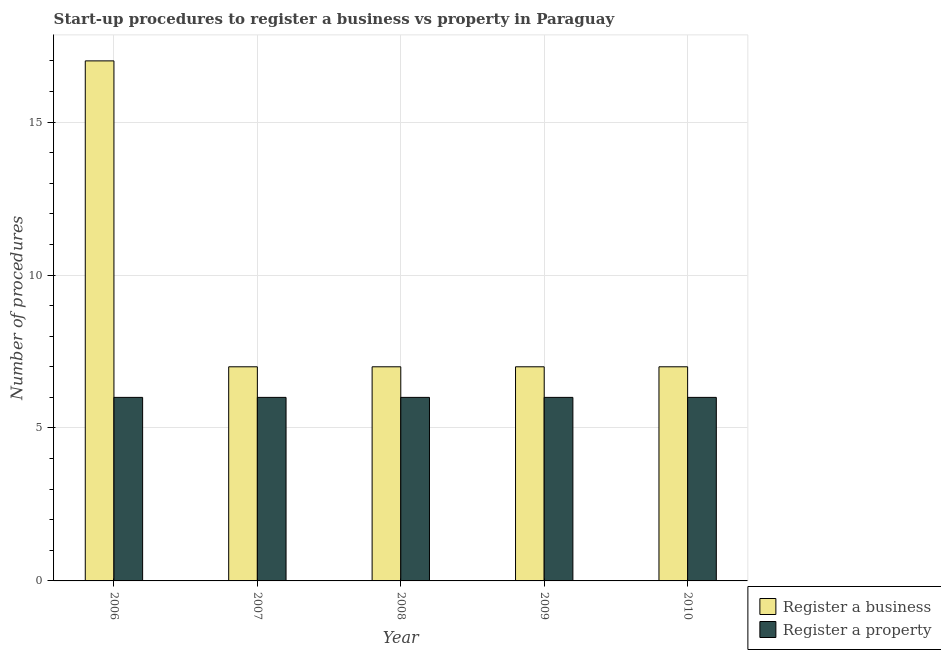How many different coloured bars are there?
Keep it short and to the point. 2. How many groups of bars are there?
Provide a short and direct response. 5. Are the number of bars on each tick of the X-axis equal?
Provide a succinct answer. Yes. How many bars are there on the 4th tick from the left?
Give a very brief answer. 2. How many bars are there on the 1st tick from the right?
Provide a short and direct response. 2. What is the number of procedures to register a business in 2008?
Provide a short and direct response. 7. Across all years, what is the maximum number of procedures to register a business?
Make the answer very short. 17. In which year was the number of procedures to register a property maximum?
Your answer should be compact. 2006. In which year was the number of procedures to register a business minimum?
Give a very brief answer. 2007. What is the total number of procedures to register a business in the graph?
Offer a very short reply. 45. What is the difference between the number of procedures to register a business in 2009 and that in 2010?
Your answer should be very brief. 0. In the year 2008, what is the difference between the number of procedures to register a property and number of procedures to register a business?
Your answer should be very brief. 0. What is the ratio of the number of procedures to register a business in 2006 to that in 2008?
Your answer should be compact. 2.43. Is the number of procedures to register a business in 2006 less than that in 2008?
Provide a short and direct response. No. What is the difference between the highest and the second highest number of procedures to register a property?
Your answer should be very brief. 0. What is the difference between the highest and the lowest number of procedures to register a business?
Your answer should be compact. 10. In how many years, is the number of procedures to register a property greater than the average number of procedures to register a property taken over all years?
Keep it short and to the point. 0. What does the 2nd bar from the left in 2007 represents?
Offer a very short reply. Register a property. What does the 1st bar from the right in 2010 represents?
Offer a terse response. Register a property. Are the values on the major ticks of Y-axis written in scientific E-notation?
Provide a succinct answer. No. Does the graph contain grids?
Your answer should be very brief. Yes. Where does the legend appear in the graph?
Give a very brief answer. Bottom right. How many legend labels are there?
Offer a terse response. 2. What is the title of the graph?
Your response must be concise. Start-up procedures to register a business vs property in Paraguay. What is the label or title of the X-axis?
Offer a very short reply. Year. What is the label or title of the Y-axis?
Your response must be concise. Number of procedures. What is the Number of procedures in Register a business in 2006?
Offer a very short reply. 17. What is the Number of procedures in Register a business in 2007?
Offer a very short reply. 7. What is the Number of procedures of Register a property in 2007?
Your answer should be very brief. 6. What is the Number of procedures of Register a property in 2008?
Provide a short and direct response. 6. What is the Number of procedures in Register a business in 2009?
Your answer should be compact. 7. What is the Number of procedures of Register a property in 2009?
Ensure brevity in your answer.  6. Across all years, what is the maximum Number of procedures in Register a business?
Your answer should be very brief. 17. Across all years, what is the minimum Number of procedures in Register a business?
Your response must be concise. 7. What is the total Number of procedures of Register a business in the graph?
Keep it short and to the point. 45. What is the difference between the Number of procedures of Register a property in 2006 and that in 2009?
Offer a very short reply. 0. What is the difference between the Number of procedures in Register a business in 2007 and that in 2008?
Make the answer very short. 0. What is the difference between the Number of procedures in Register a business in 2007 and that in 2009?
Ensure brevity in your answer.  0. What is the difference between the Number of procedures of Register a property in 2007 and that in 2009?
Make the answer very short. 0. What is the difference between the Number of procedures of Register a business in 2007 and that in 2010?
Give a very brief answer. 0. What is the difference between the Number of procedures of Register a business in 2008 and that in 2010?
Give a very brief answer. 0. What is the difference between the Number of procedures in Register a property in 2009 and that in 2010?
Your answer should be very brief. 0. What is the difference between the Number of procedures in Register a business in 2006 and the Number of procedures in Register a property in 2009?
Your response must be concise. 11. What is the difference between the Number of procedures in Register a business in 2007 and the Number of procedures in Register a property in 2008?
Offer a very short reply. 1. What is the difference between the Number of procedures of Register a business in 2007 and the Number of procedures of Register a property in 2010?
Offer a very short reply. 1. What is the difference between the Number of procedures of Register a business in 2008 and the Number of procedures of Register a property in 2009?
Your answer should be very brief. 1. What is the difference between the Number of procedures in Register a business in 2008 and the Number of procedures in Register a property in 2010?
Provide a succinct answer. 1. What is the difference between the Number of procedures of Register a business in 2009 and the Number of procedures of Register a property in 2010?
Your answer should be very brief. 1. What is the average Number of procedures in Register a business per year?
Offer a terse response. 9. What is the average Number of procedures in Register a property per year?
Make the answer very short. 6. In the year 2007, what is the difference between the Number of procedures in Register a business and Number of procedures in Register a property?
Provide a succinct answer. 1. In the year 2009, what is the difference between the Number of procedures in Register a business and Number of procedures in Register a property?
Provide a short and direct response. 1. In the year 2010, what is the difference between the Number of procedures in Register a business and Number of procedures in Register a property?
Keep it short and to the point. 1. What is the ratio of the Number of procedures of Register a business in 2006 to that in 2007?
Your answer should be very brief. 2.43. What is the ratio of the Number of procedures in Register a business in 2006 to that in 2008?
Your response must be concise. 2.43. What is the ratio of the Number of procedures of Register a property in 2006 to that in 2008?
Offer a terse response. 1. What is the ratio of the Number of procedures of Register a business in 2006 to that in 2009?
Offer a terse response. 2.43. What is the ratio of the Number of procedures in Register a property in 2006 to that in 2009?
Your answer should be compact. 1. What is the ratio of the Number of procedures in Register a business in 2006 to that in 2010?
Ensure brevity in your answer.  2.43. What is the ratio of the Number of procedures in Register a property in 2006 to that in 2010?
Your answer should be compact. 1. What is the ratio of the Number of procedures in Register a business in 2007 to that in 2009?
Your answer should be very brief. 1. What is the ratio of the Number of procedures in Register a property in 2007 to that in 2009?
Keep it short and to the point. 1. What is the ratio of the Number of procedures in Register a business in 2007 to that in 2010?
Provide a succinct answer. 1. What is the ratio of the Number of procedures in Register a property in 2007 to that in 2010?
Keep it short and to the point. 1. What is the ratio of the Number of procedures in Register a business in 2008 to that in 2010?
Keep it short and to the point. 1. What is the ratio of the Number of procedures in Register a property in 2008 to that in 2010?
Make the answer very short. 1. What is the difference between the highest and the second highest Number of procedures in Register a business?
Provide a succinct answer. 10. What is the difference between the highest and the lowest Number of procedures of Register a property?
Give a very brief answer. 0. 